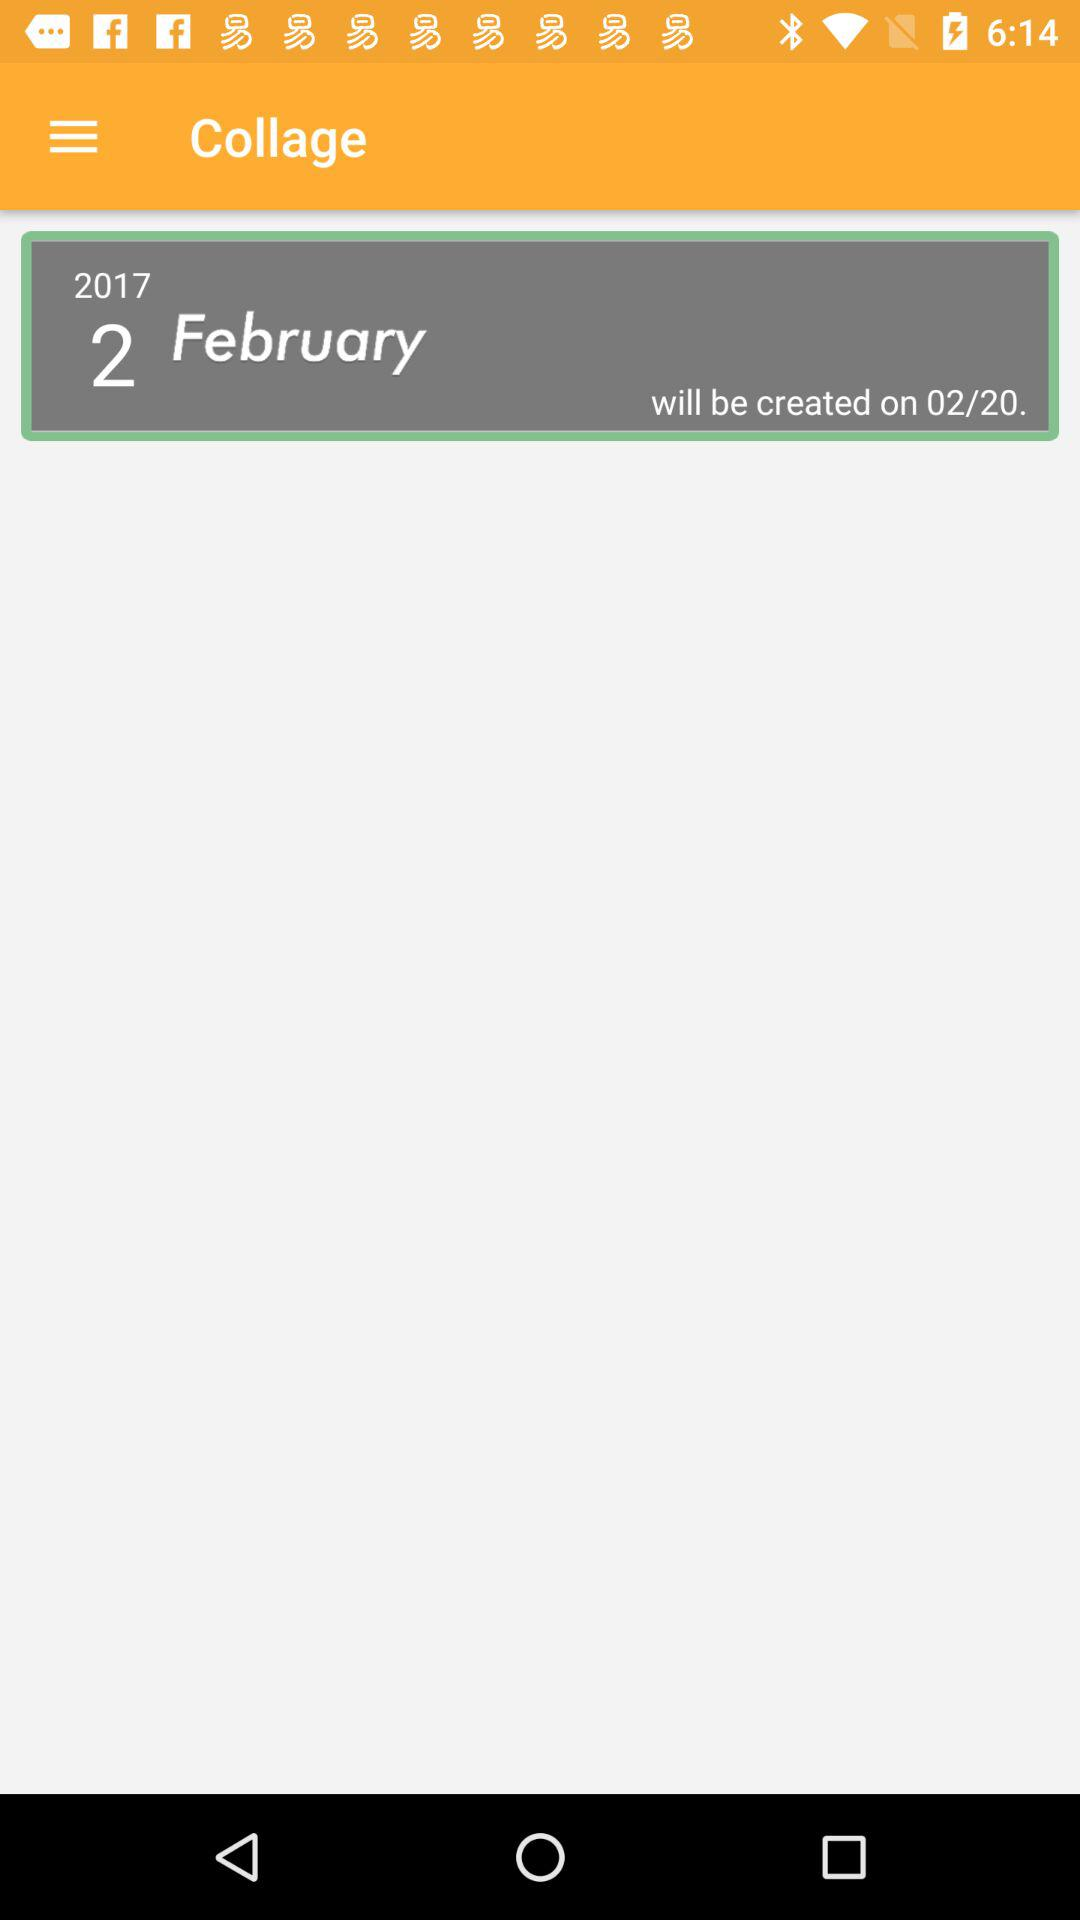When will it be created? It will be created on February 20, 2017. 